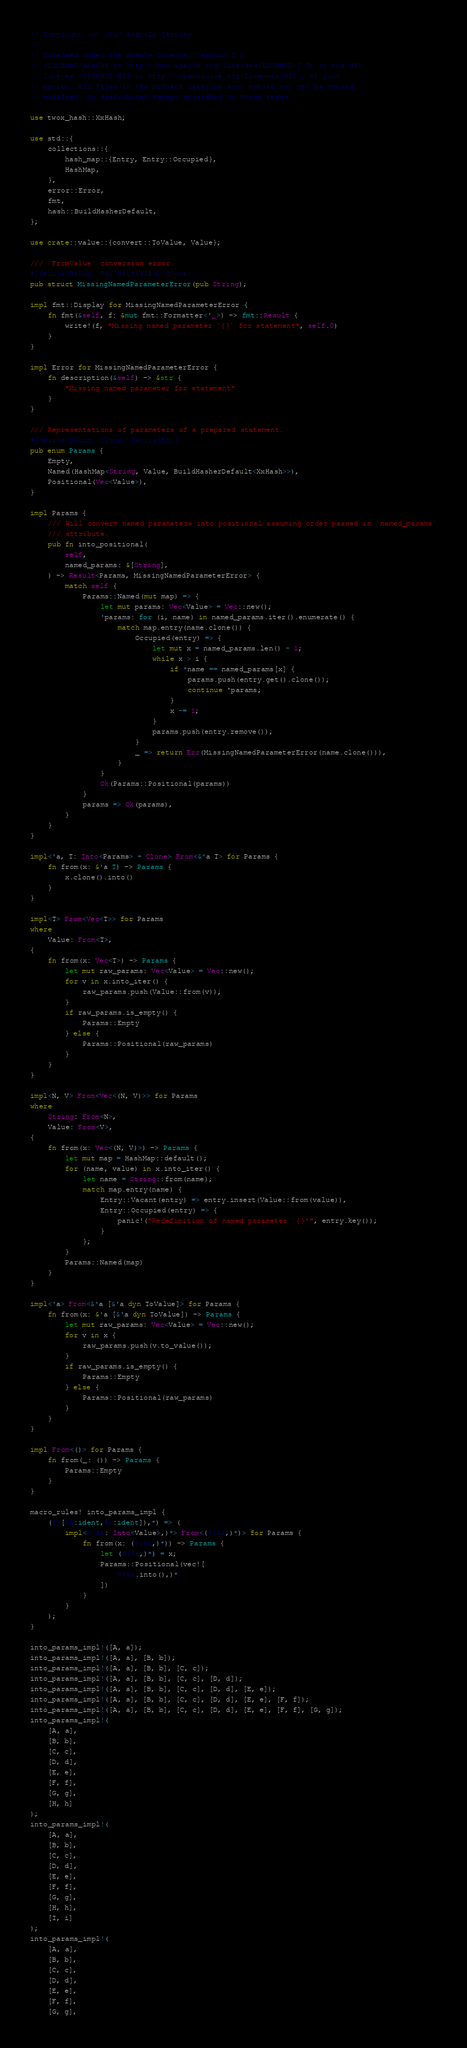<code> <loc_0><loc_0><loc_500><loc_500><_Rust_>// Copyright (c) 2017 Anatoly Ikorsky
//
// Licensed under the Apache License, Version 2.0
// <LICENSE-APACHE or http://www.apache.org/licenses/LICENSE-2.0> or the MIT
// license <LICENSE-MIT or http://opensource.org/licenses/MIT>, at your
// option. All files in the project carrying such notice may not be copied,
// modified, or distributed except according to those terms.

use twox_hash::XxHash;

use std::{
    collections::{
        hash_map::{Entry, Entry::Occupied},
        HashMap,
    },
    error::Error,
    fmt,
    hash::BuildHasherDefault,
};

use crate::value::{convert::ToValue, Value};

/// `FromValue` conversion error.
#[derive(Debug, Eq, PartialEq, Clone)]
pub struct MissingNamedParameterError(pub String);

impl fmt::Display for MissingNamedParameterError {
    fn fmt(&self, f: &mut fmt::Formatter<'_>) -> fmt::Result {
        write!(f, "Missing named parameter `{}` for statement", self.0)
    }
}

impl Error for MissingNamedParameterError {
    fn description(&self) -> &str {
        "Missing named parameter for statement"
    }
}

/// Representations of parameters of a prepared statement.
#[derive(Debug, Clone, PartialEq)]
pub enum Params {
    Empty,
    Named(HashMap<String, Value, BuildHasherDefault<XxHash>>),
    Positional(Vec<Value>),
}

impl Params {
    /// Will convert named parameters into positional assuming order passed in `named_params`
    /// attribute.
    pub fn into_positional(
        self,
        named_params: &[String],
    ) -> Result<Params, MissingNamedParameterError> {
        match self {
            Params::Named(mut map) => {
                let mut params: Vec<Value> = Vec::new();
                'params: for (i, name) in named_params.iter().enumerate() {
                    match map.entry(name.clone()) {
                        Occupied(entry) => {
                            let mut x = named_params.len() - 1;
                            while x > i {
                                if *name == named_params[x] {
                                    params.push(entry.get().clone());
                                    continue 'params;
                                }
                                x -= 1;
                            }
                            params.push(entry.remove());
                        }
                        _ => return Err(MissingNamedParameterError(name.clone())),
                    }
                }
                Ok(Params::Positional(params))
            }
            params => Ok(params),
        }
    }
}

impl<'a, T: Into<Params> + Clone> From<&'a T> for Params {
    fn from(x: &'a T) -> Params {
        x.clone().into()
    }
}

impl<T> From<Vec<T>> for Params
where
    Value: From<T>,
{
    fn from(x: Vec<T>) -> Params {
        let mut raw_params: Vec<Value> = Vec::new();
        for v in x.into_iter() {
            raw_params.push(Value::from(v));
        }
        if raw_params.is_empty() {
            Params::Empty
        } else {
            Params::Positional(raw_params)
        }
    }
}

impl<N, V> From<Vec<(N, V)>> for Params
where
    String: From<N>,
    Value: From<V>,
{
    fn from(x: Vec<(N, V)>) -> Params {
        let mut map = HashMap::default();
        for (name, value) in x.into_iter() {
            let name = String::from(name);
            match map.entry(name) {
                Entry::Vacant(entry) => entry.insert(Value::from(value)),
                Entry::Occupied(entry) => {
                    panic!("Redefinition of named parameter `{}'", entry.key());
                }
            };
        }
        Params::Named(map)
    }
}

impl<'a> From<&'a [&'a dyn ToValue]> for Params {
    fn from(x: &'a [&'a dyn ToValue]) -> Params {
        let mut raw_params: Vec<Value> = Vec::new();
        for v in x {
            raw_params.push(v.to_value());
        }
        if raw_params.is_empty() {
            Params::Empty
        } else {
            Params::Positional(raw_params)
        }
    }
}

impl From<()> for Params {
    fn from(_: ()) -> Params {
        Params::Empty
    }
}

macro_rules! into_params_impl {
    ($([$A:ident,$a:ident]),*) => (
        impl<$($A: Into<Value>,)*> From<($($A,)*)> for Params {
            fn from(x: ($($A,)*)) -> Params {
                let ($($a,)*) = x;
                Params::Positional(vec![
                    $($a.into(),)*
                ])
            }
        }
    );
}

into_params_impl!([A, a]);
into_params_impl!([A, a], [B, b]);
into_params_impl!([A, a], [B, b], [C, c]);
into_params_impl!([A, a], [B, b], [C, c], [D, d]);
into_params_impl!([A, a], [B, b], [C, c], [D, d], [E, e]);
into_params_impl!([A, a], [B, b], [C, c], [D, d], [E, e], [F, f]);
into_params_impl!([A, a], [B, b], [C, c], [D, d], [E, e], [F, f], [G, g]);
into_params_impl!(
    [A, a],
    [B, b],
    [C, c],
    [D, d],
    [E, e],
    [F, f],
    [G, g],
    [H, h]
);
into_params_impl!(
    [A, a],
    [B, b],
    [C, c],
    [D, d],
    [E, e],
    [F, f],
    [G, g],
    [H, h],
    [I, i]
);
into_params_impl!(
    [A, a],
    [B, b],
    [C, c],
    [D, d],
    [E, e],
    [F, f],
    [G, g],</code> 